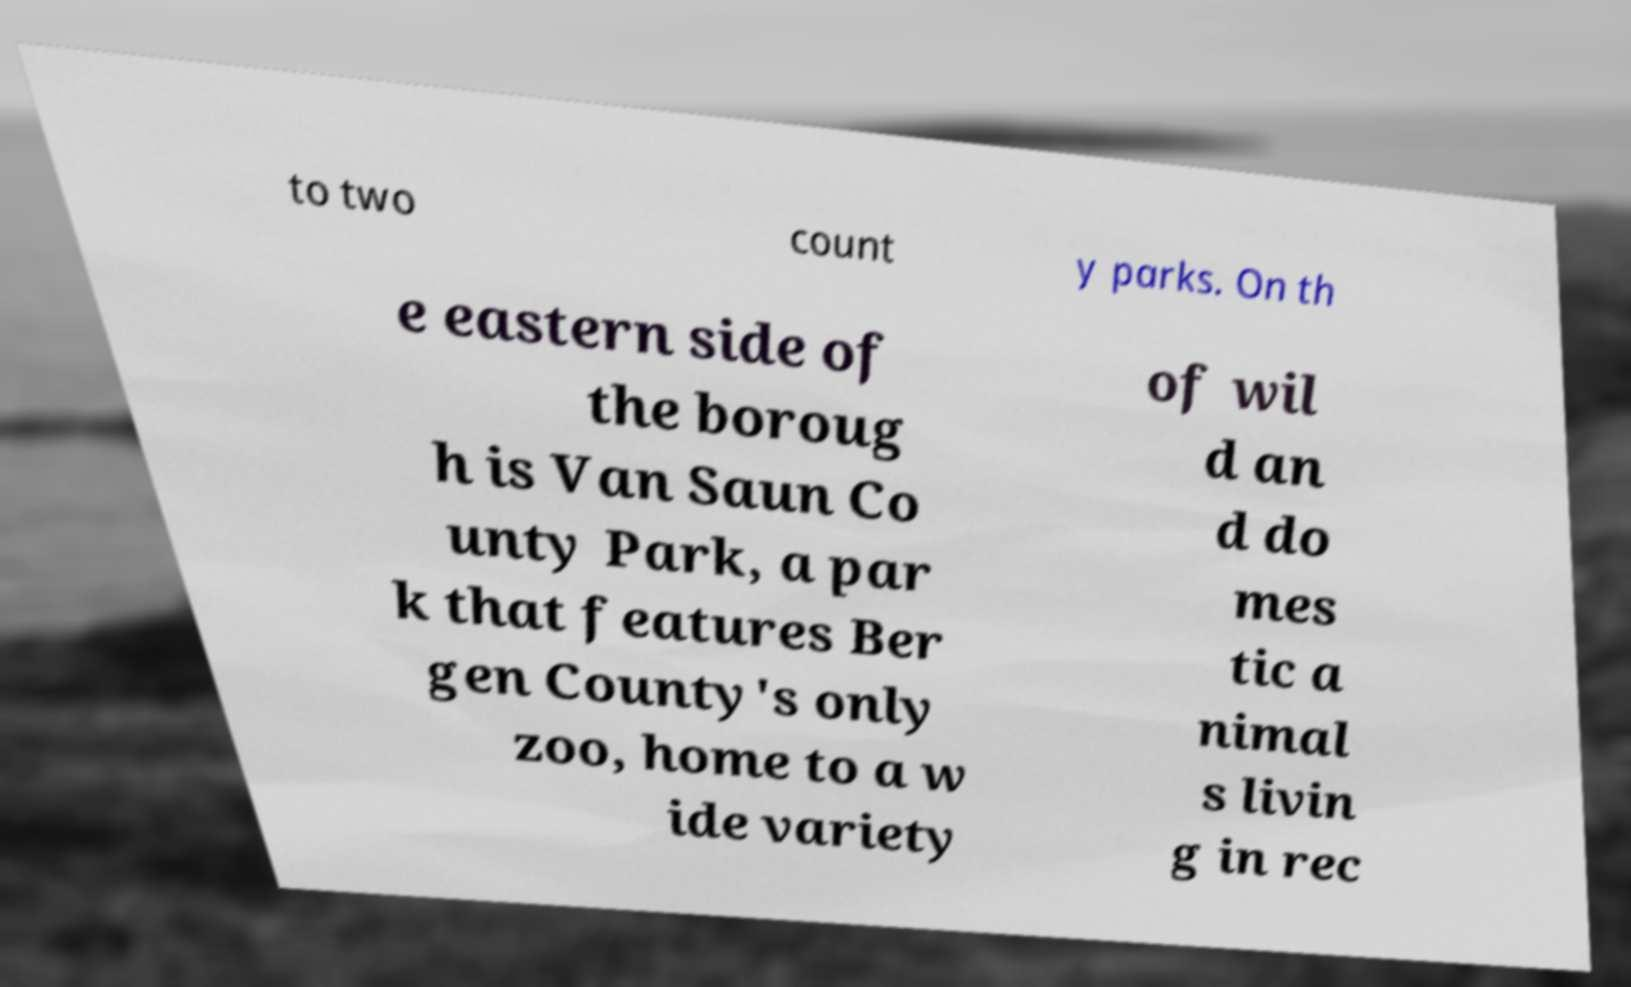There's text embedded in this image that I need extracted. Can you transcribe it verbatim? to two count y parks. On th e eastern side of the boroug h is Van Saun Co unty Park, a par k that features Ber gen County's only zoo, home to a w ide variety of wil d an d do mes tic a nimal s livin g in rec 